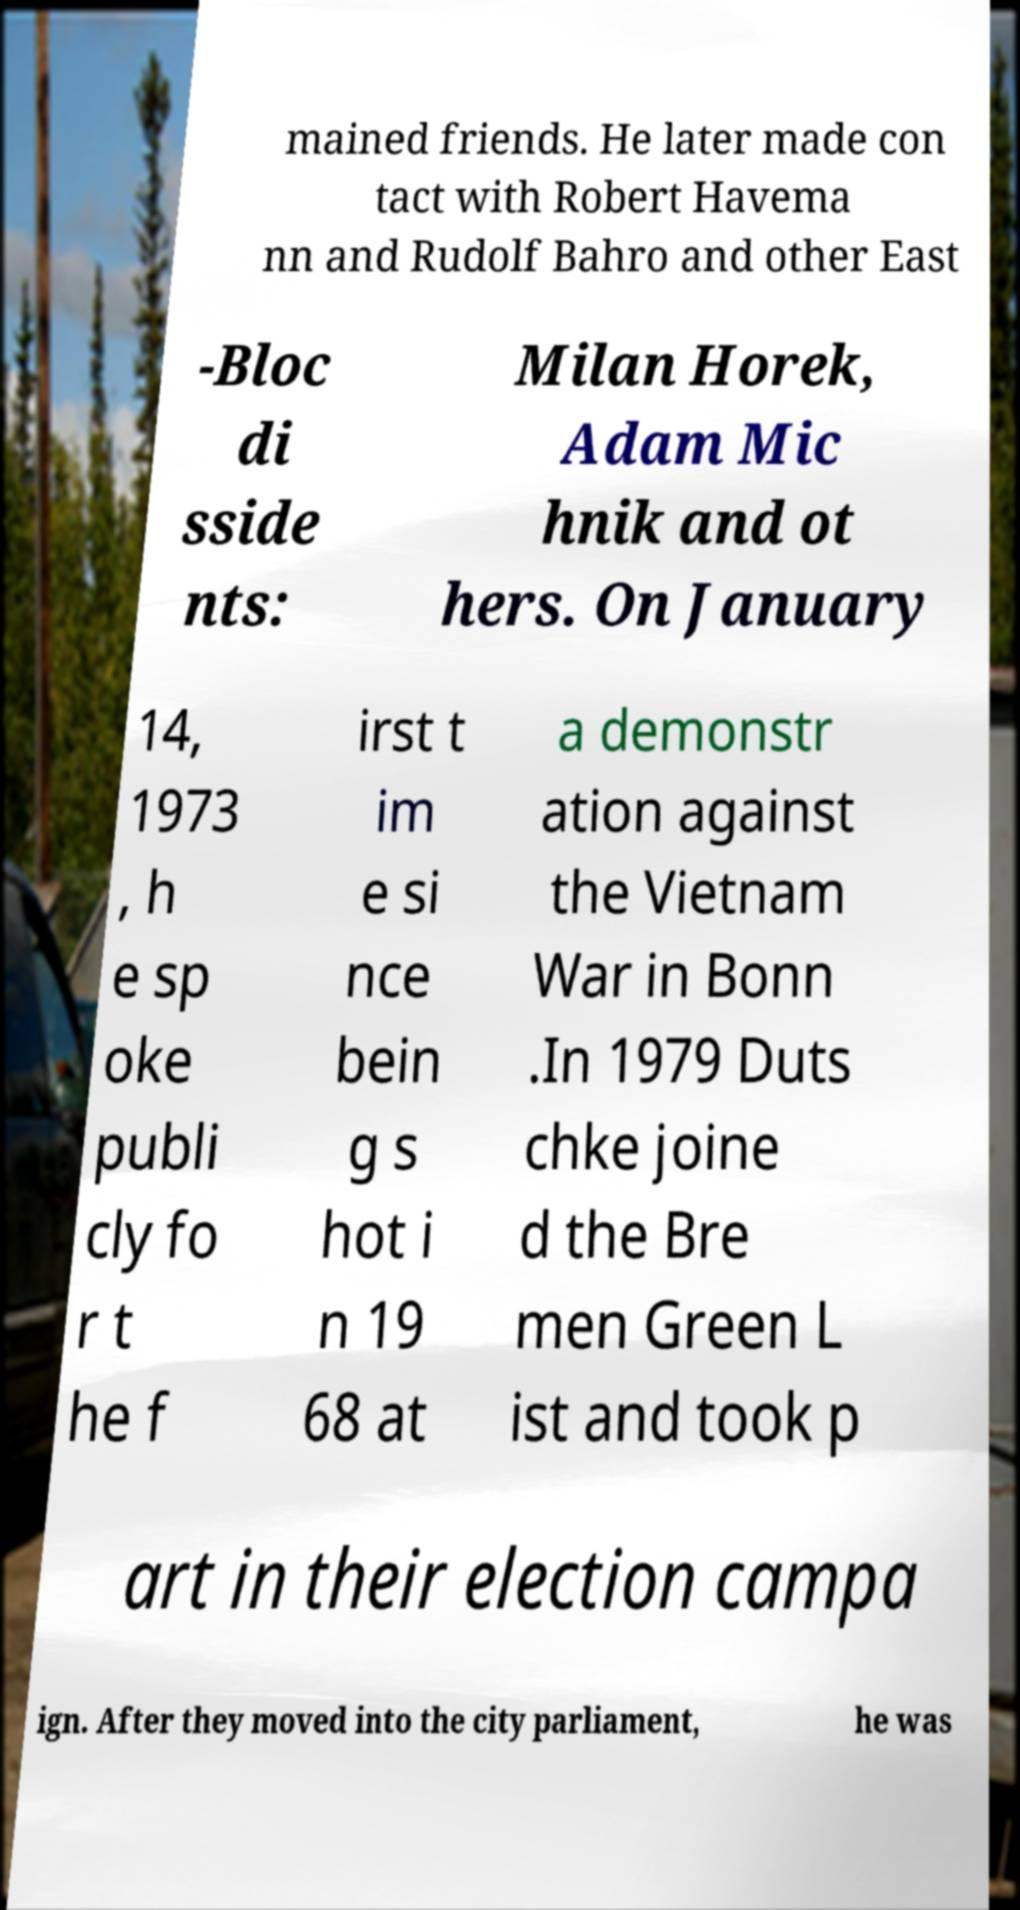Can you read and provide the text displayed in the image?This photo seems to have some interesting text. Can you extract and type it out for me? mained friends. He later made con tact with Robert Havema nn and Rudolf Bahro and other East -Bloc di sside nts: Milan Horek, Adam Mic hnik and ot hers. On January 14, 1973 , h e sp oke publi cly fo r t he f irst t im e si nce bein g s hot i n 19 68 at a demonstr ation against the Vietnam War in Bonn .In 1979 Duts chke joine d the Bre men Green L ist and took p art in their election campa ign. After they moved into the city parliament, he was 